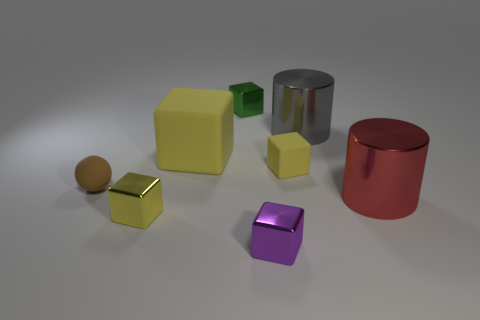Does the purple object that is in front of the green shiny cube have the same material as the tiny block that is to the right of the purple metallic block?
Provide a succinct answer. No. There is a big red thing that is the same shape as the gray thing; what material is it?
Make the answer very short. Metal. Do the tiny sphere and the big gray thing have the same material?
Provide a succinct answer. No. The tiny matte object left of the matte object that is to the right of the purple thing is what color?
Your answer should be very brief. Brown. There is a gray cylinder that is made of the same material as the purple object; what size is it?
Your response must be concise. Large. What number of red objects are the same shape as the tiny purple metal object?
Keep it short and to the point. 0. What number of objects are small yellow things on the right side of the purple object or yellow blocks right of the purple metal cube?
Keep it short and to the point. 1. What number of tiny purple shiny objects are behind the small matte thing that is to the right of the brown sphere?
Offer a very short reply. 0. There is a small yellow object that is to the left of the green metallic thing; is its shape the same as the yellow rubber object that is in front of the big cube?
Make the answer very short. Yes. What is the shape of the large object that is the same color as the tiny rubber block?
Provide a short and direct response. Cube. 